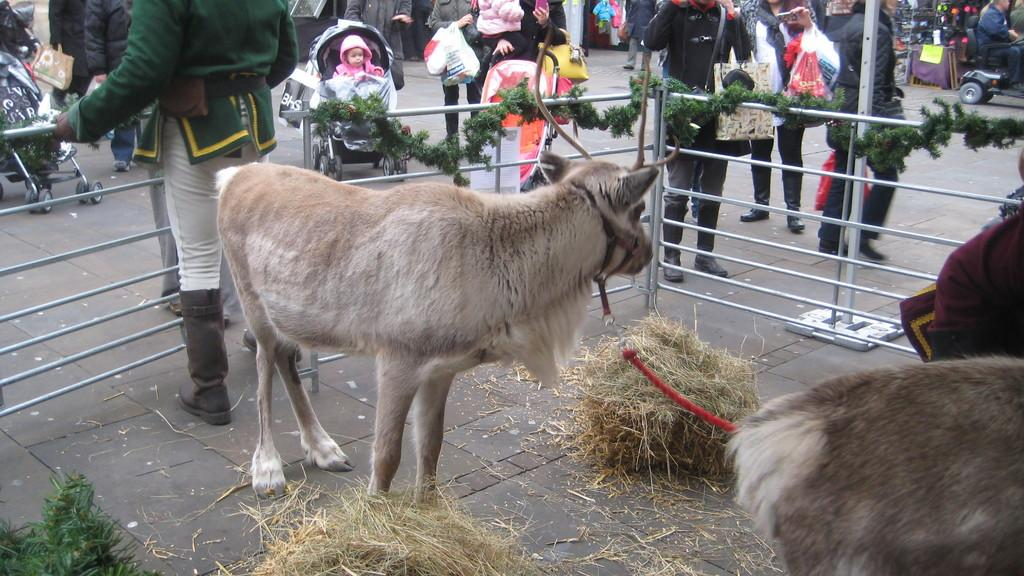What types of living organisms can be seen in the image? There are animals in the image. What objects can be seen in the image that might be used for decoration or as a barrier? Dried grass bundles and iron grills can be seen in the image. What type of decorative item is present in the image? Garlands are present in the image. Can you describe the people in the background of the image? There is a group of people standing in the background of the image. What other unspecified items can be seen in the image? There are some other unspecified items in the image. What type of cloud can be seen in the image? There is no cloud present in the image. What type of flame is visible in the image? There is no flame present in the image. What type of industrial equipment can be seen in the image? There is no industrial equipment present in the image. 